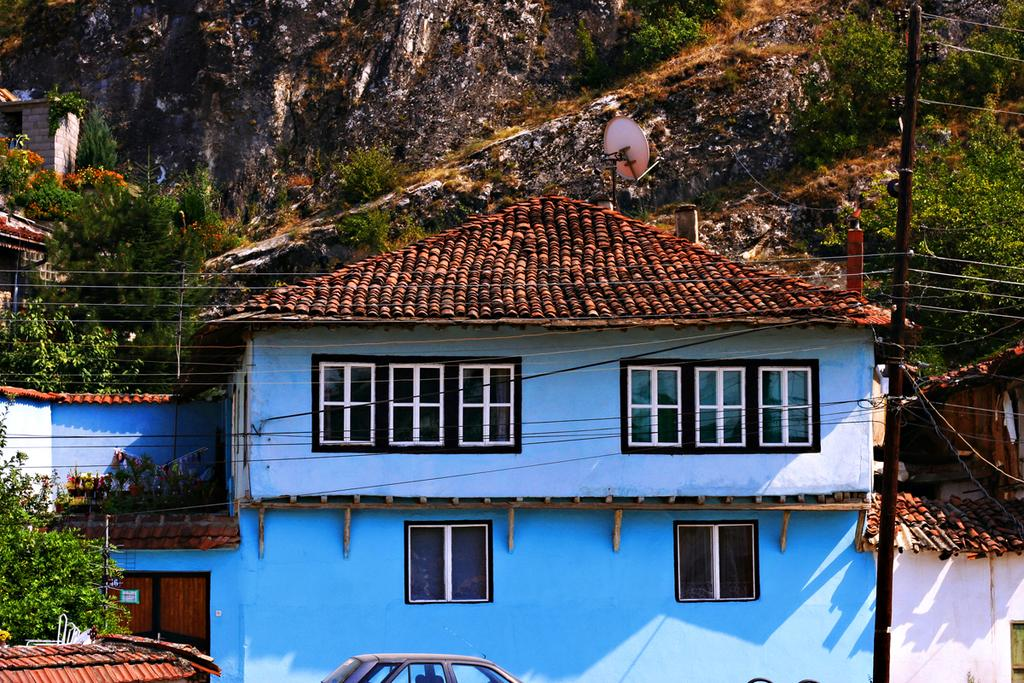What is the main subject of the image? There is a vehicle in the image. What can be seen inside the vehicle? The vehicle has windows, which suggests that there might be a view of the surroundings. What type of structures are visible in the image? There are buildings in the image. What is attached to the vehicle? There is an antenna in the image, which might be used for communication or other purposes. What other objects can be seen in the image? There are poles, wires, trees, and mountains in the image. What type of line is visible in the image? There is no line present in the image. What type of tank is visible in the image? There is no tank present in the image. 